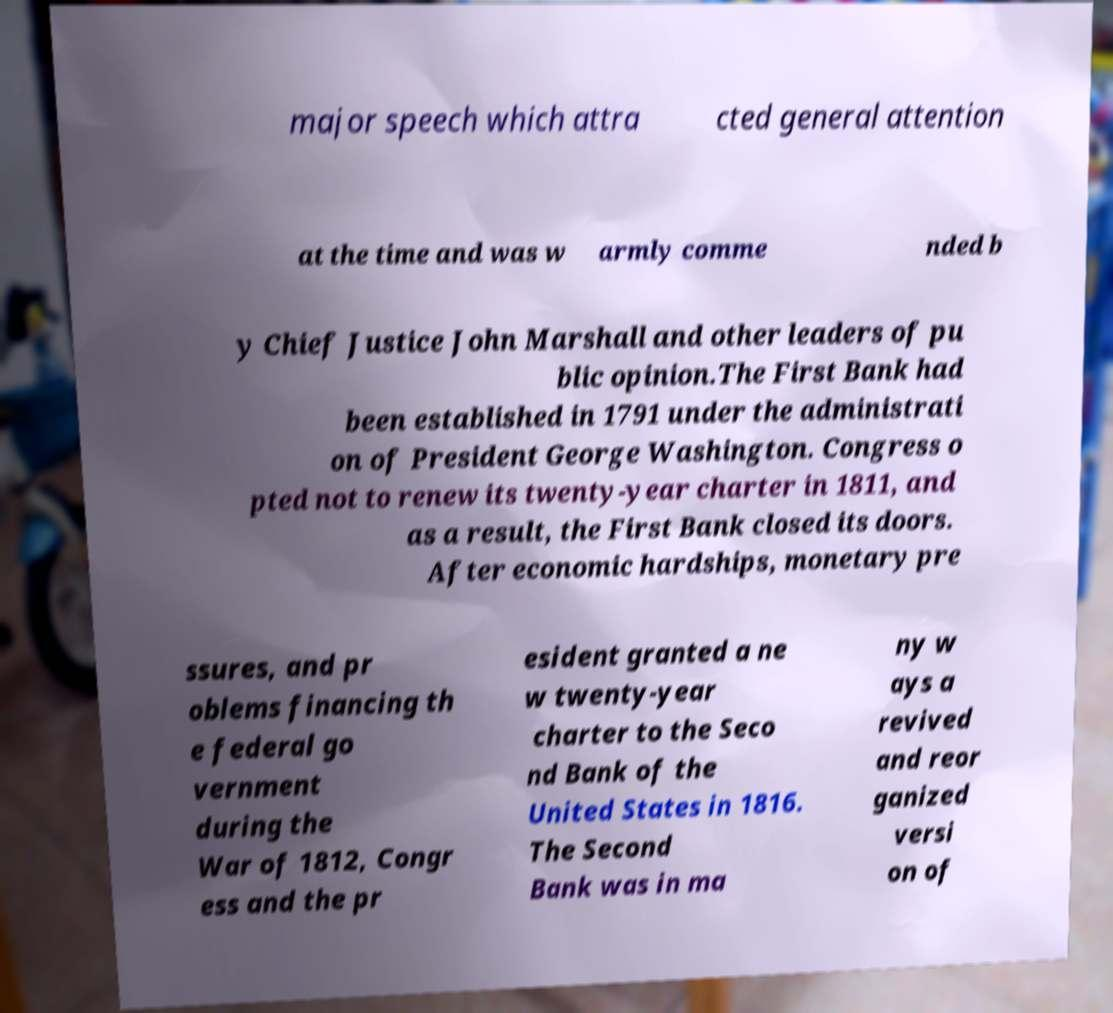Could you extract and type out the text from this image? major speech which attra cted general attention at the time and was w armly comme nded b y Chief Justice John Marshall and other leaders of pu blic opinion.The First Bank had been established in 1791 under the administrati on of President George Washington. Congress o pted not to renew its twenty-year charter in 1811, and as a result, the First Bank closed its doors. After economic hardships, monetary pre ssures, and pr oblems financing th e federal go vernment during the War of 1812, Congr ess and the pr esident granted a ne w twenty-year charter to the Seco nd Bank of the United States in 1816. The Second Bank was in ma ny w ays a revived and reor ganized versi on of 